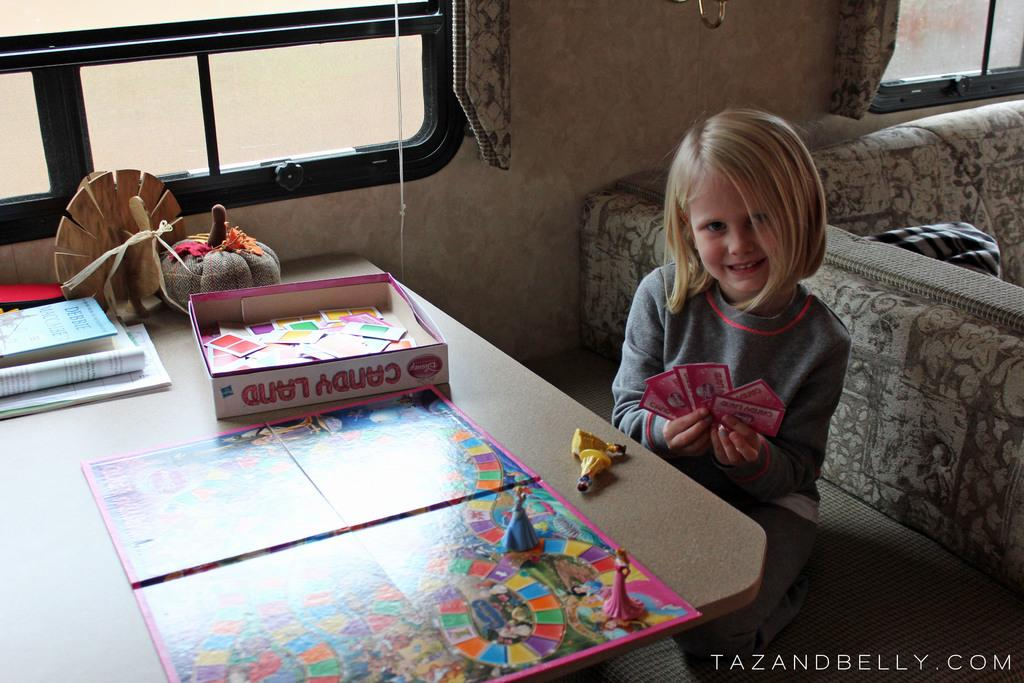<image>
Summarize the visual content of the image. A little girl sits at a table and plays the Candy Land game. 